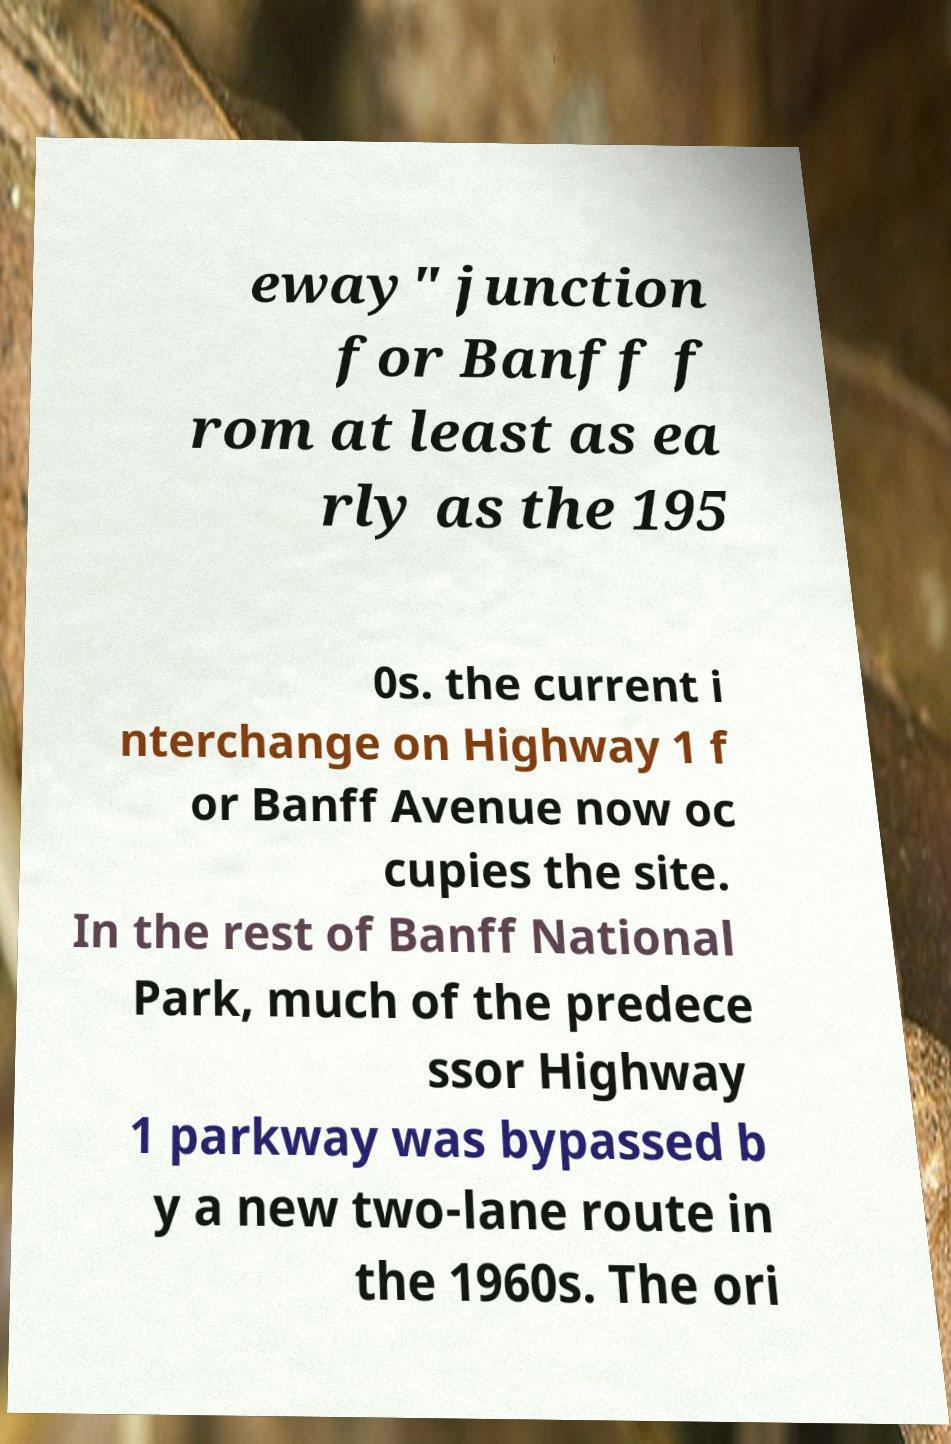Could you extract and type out the text from this image? eway" junction for Banff f rom at least as ea rly as the 195 0s. the current i nterchange on Highway 1 f or Banff Avenue now oc cupies the site. In the rest of Banff National Park, much of the predece ssor Highway 1 parkway was bypassed b y a new two-lane route in the 1960s. The ori 